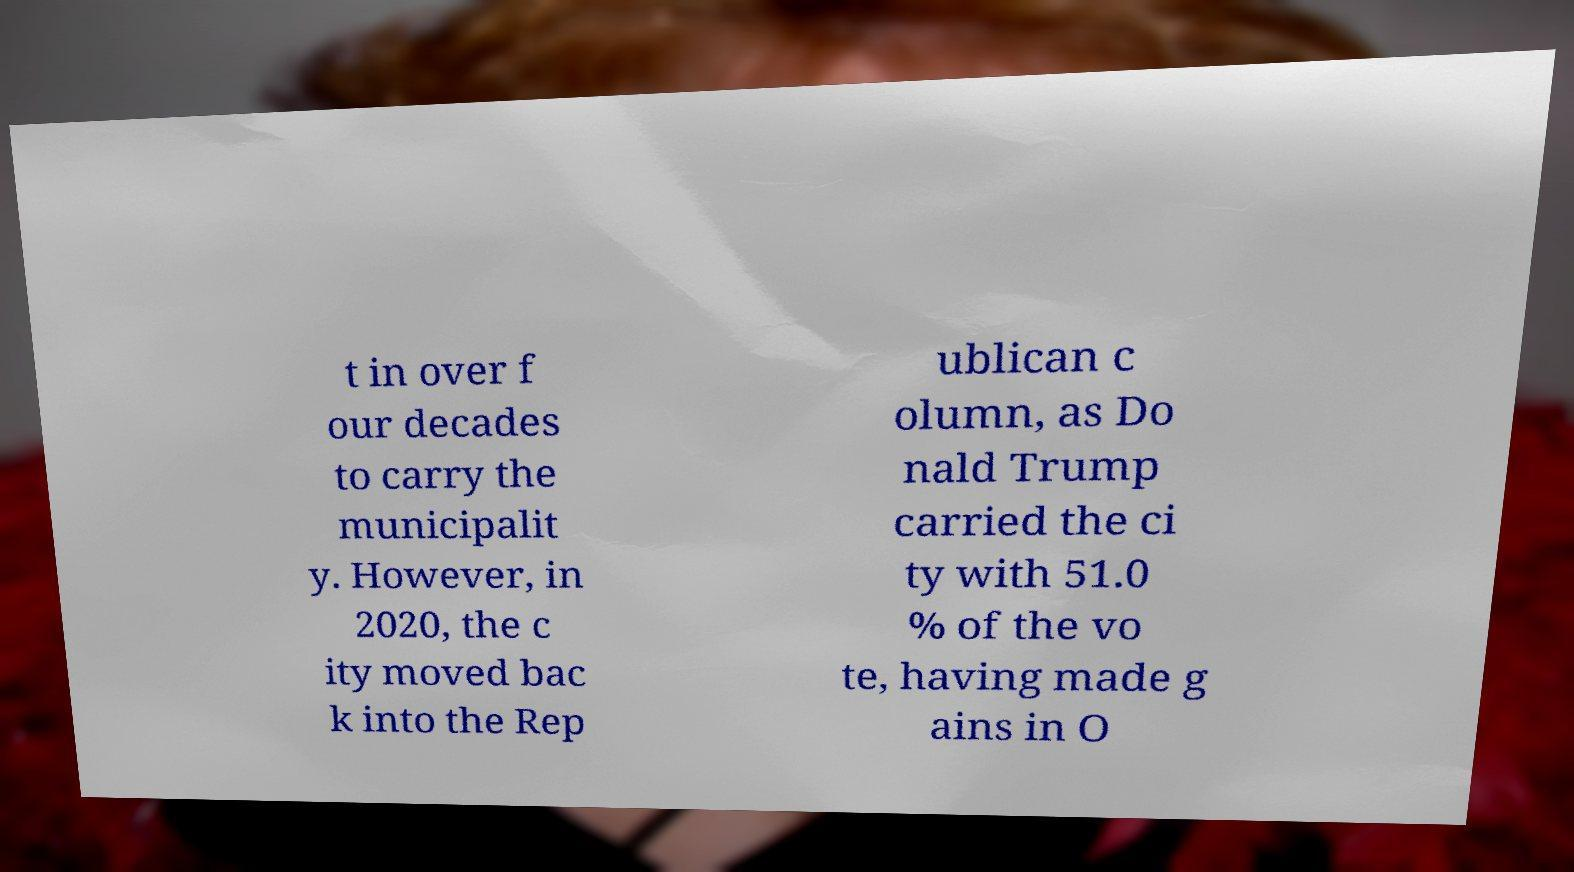Could you extract and type out the text from this image? t in over f our decades to carry the municipalit y. However, in 2020, the c ity moved bac k into the Rep ublican c olumn, as Do nald Trump carried the ci ty with 51.0 % of the vo te, having made g ains in O 